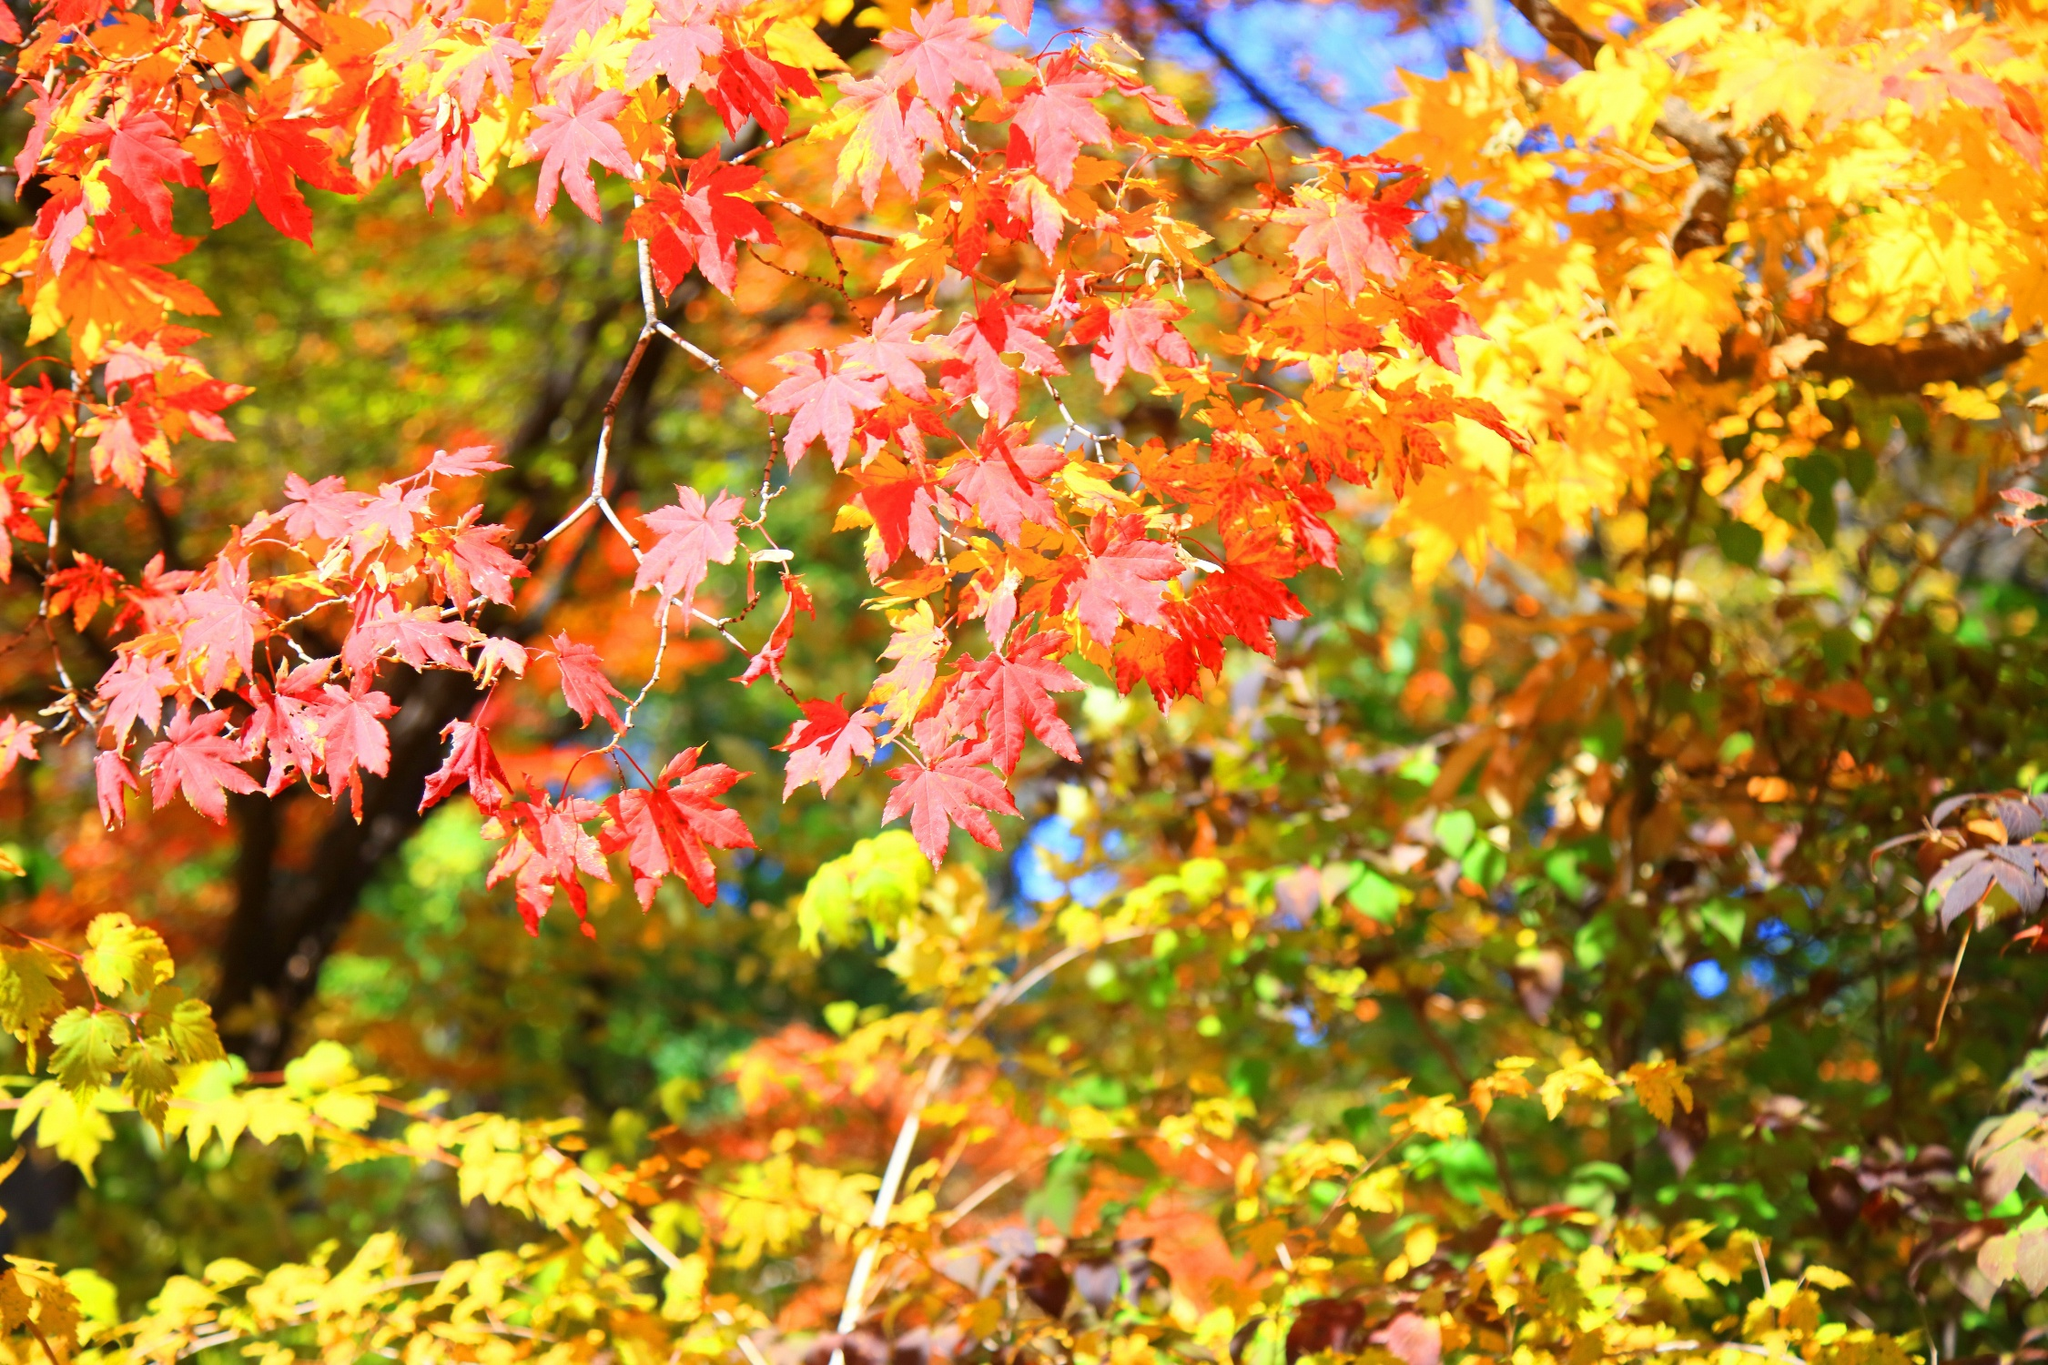Describe the different colors you can observe in the image. In the image, the tree leaves display a beautiful gradient of fall colors. The most prominent are the vibrant reds, contrasting with the warm oranges and the bright yellows. These colors intermingle with shades of green, indicating leaves that are yet to transition into autumn. The mix creates a rich tapestry reflective of a quintessential autumn scene. 